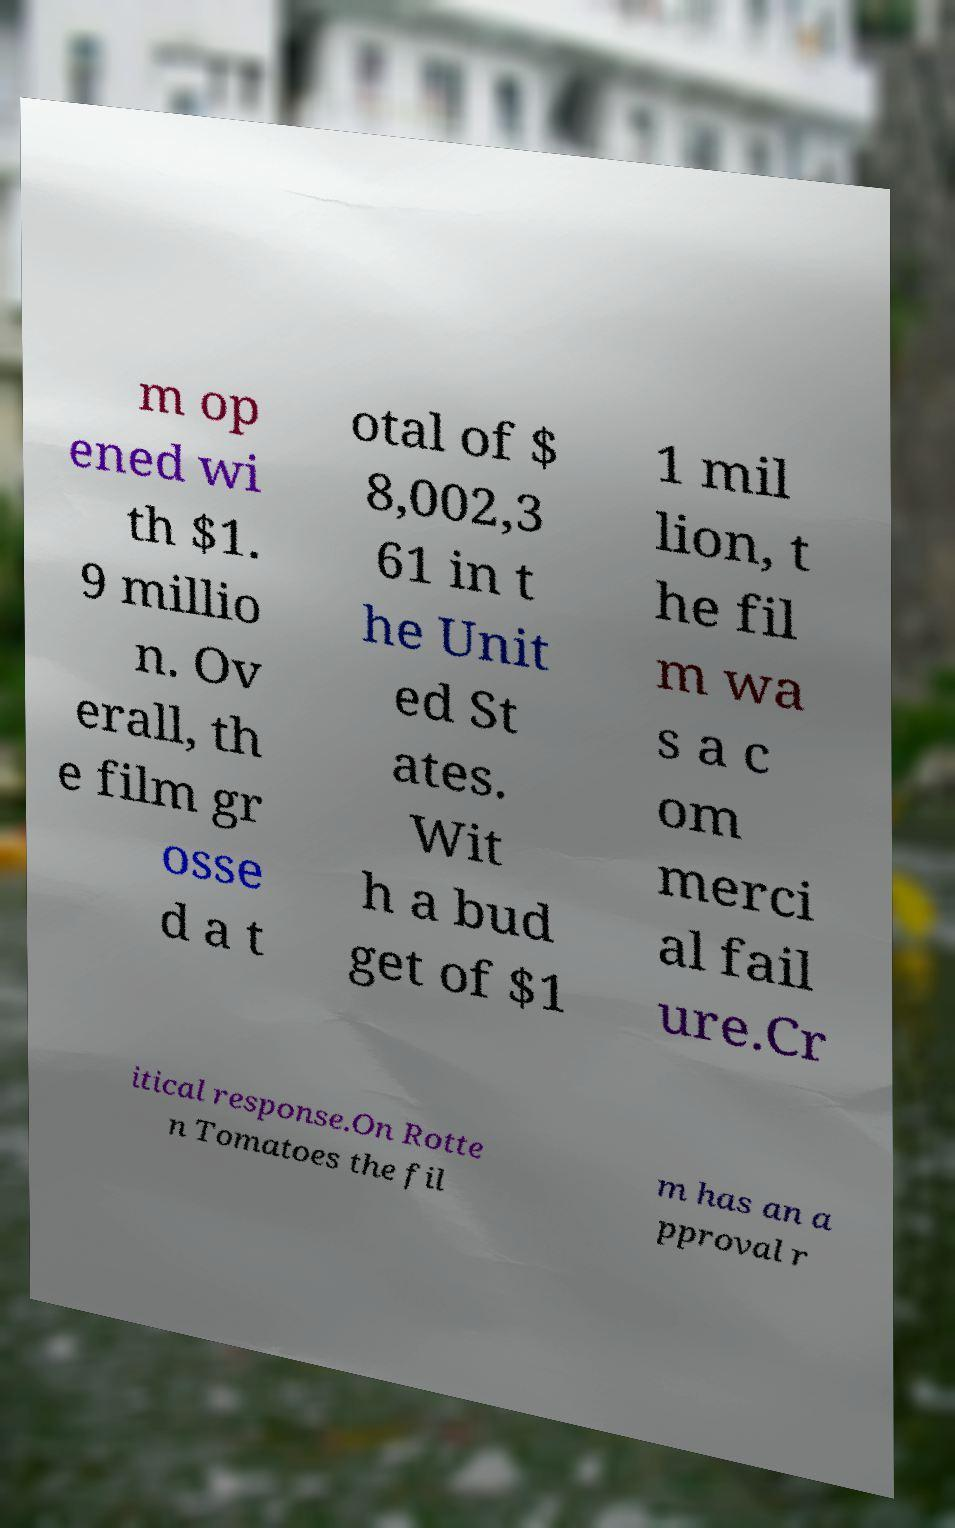There's text embedded in this image that I need extracted. Can you transcribe it verbatim? m op ened wi th $1. 9 millio n. Ov erall, th e film gr osse d a t otal of $ 8,002,3 61 in t he Unit ed St ates. Wit h a bud get of $1 1 mil lion, t he fil m wa s a c om merci al fail ure.Cr itical response.On Rotte n Tomatoes the fil m has an a pproval r 